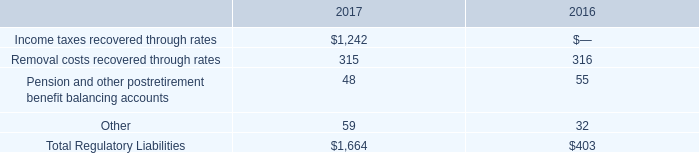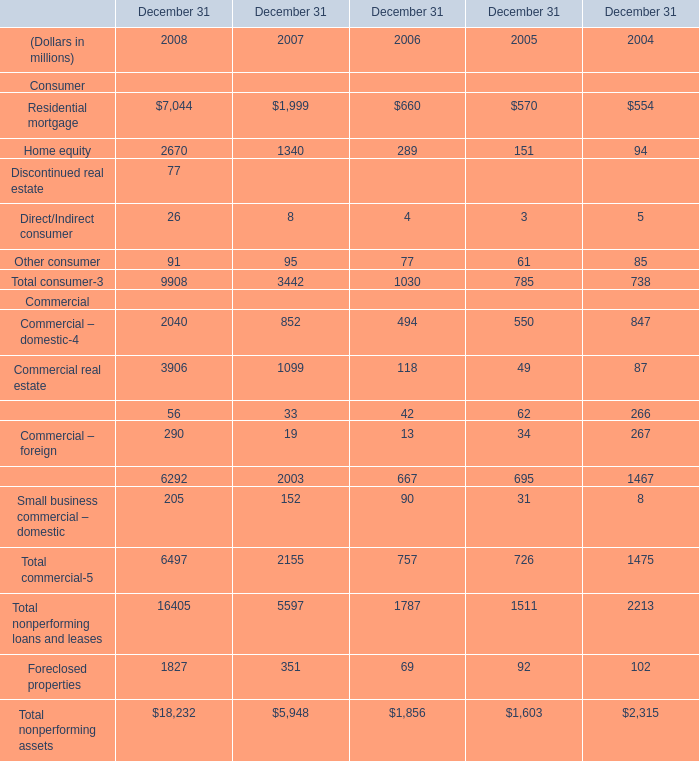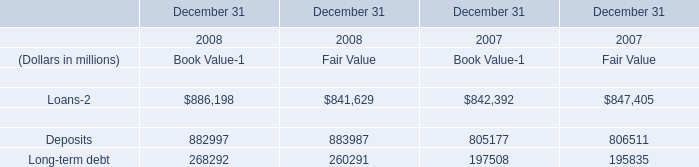what was the growth rate of the regulatory liability from 2016 to 2017 
Computations: ((1664 - 403) / 403)
Answer: 3.12903. 